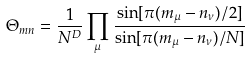<formula> <loc_0><loc_0><loc_500><loc_500>\Theta _ { m n } = \frac { 1 } { N ^ { D } } \prod _ { \mu } \frac { \sin [ \pi ( m _ { \mu } - n _ { \nu } ) / 2 ] } { \sin [ \pi ( m _ { \mu } - n _ { \nu } ) / N ] }</formula> 